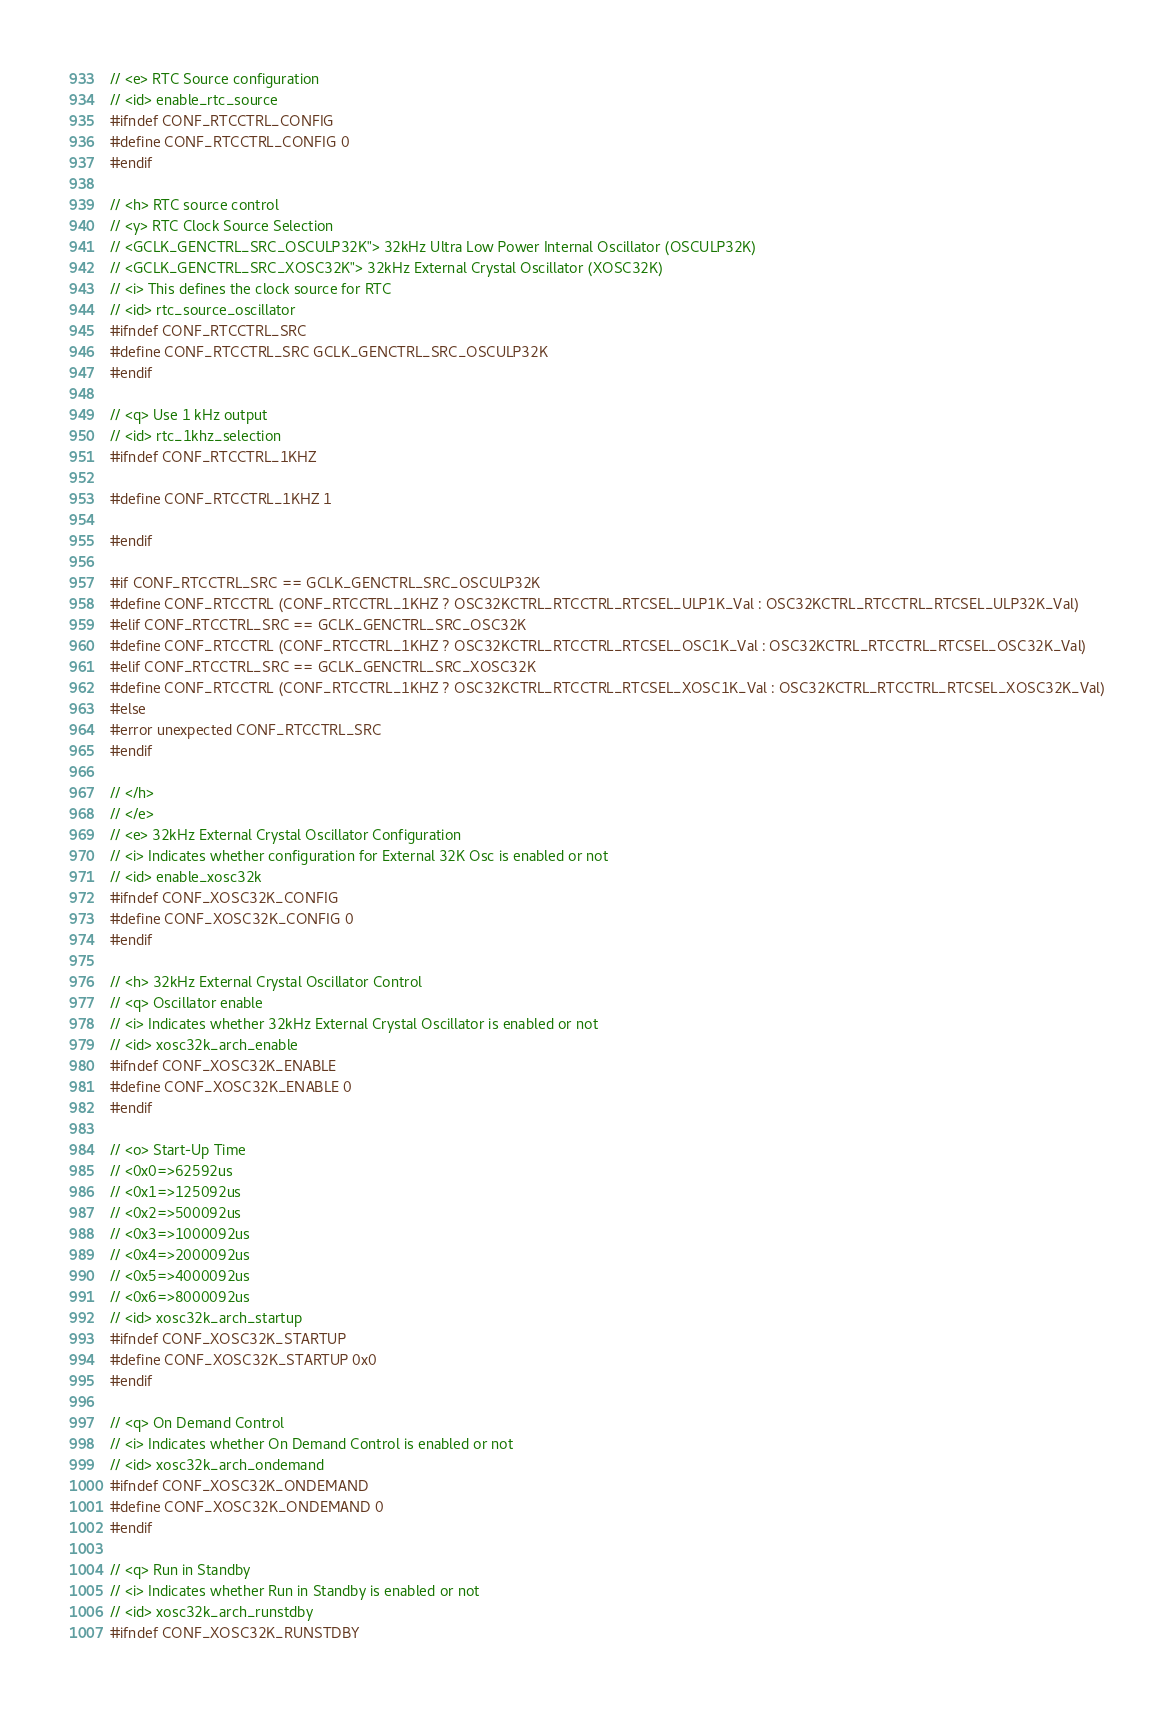<code> <loc_0><loc_0><loc_500><loc_500><_C_>
// <e> RTC Source configuration
// <id> enable_rtc_source
#ifndef CONF_RTCCTRL_CONFIG
#define CONF_RTCCTRL_CONFIG 0
#endif

// <h> RTC source control
// <y> RTC Clock Source Selection
// <GCLK_GENCTRL_SRC_OSCULP32K"> 32kHz Ultra Low Power Internal Oscillator (OSCULP32K)
// <GCLK_GENCTRL_SRC_XOSC32K"> 32kHz External Crystal Oscillator (XOSC32K)
// <i> This defines the clock source for RTC
// <id> rtc_source_oscillator
#ifndef CONF_RTCCTRL_SRC
#define CONF_RTCCTRL_SRC GCLK_GENCTRL_SRC_OSCULP32K
#endif

// <q> Use 1 kHz output
// <id> rtc_1khz_selection
#ifndef CONF_RTCCTRL_1KHZ

#define CONF_RTCCTRL_1KHZ 1

#endif

#if CONF_RTCCTRL_SRC == GCLK_GENCTRL_SRC_OSCULP32K
#define CONF_RTCCTRL (CONF_RTCCTRL_1KHZ ? OSC32KCTRL_RTCCTRL_RTCSEL_ULP1K_Val : OSC32KCTRL_RTCCTRL_RTCSEL_ULP32K_Val)
#elif CONF_RTCCTRL_SRC == GCLK_GENCTRL_SRC_OSC32K
#define CONF_RTCCTRL (CONF_RTCCTRL_1KHZ ? OSC32KCTRL_RTCCTRL_RTCSEL_OSC1K_Val : OSC32KCTRL_RTCCTRL_RTCSEL_OSC32K_Val)
#elif CONF_RTCCTRL_SRC == GCLK_GENCTRL_SRC_XOSC32K
#define CONF_RTCCTRL (CONF_RTCCTRL_1KHZ ? OSC32KCTRL_RTCCTRL_RTCSEL_XOSC1K_Val : OSC32KCTRL_RTCCTRL_RTCSEL_XOSC32K_Val)
#else
#error unexpected CONF_RTCCTRL_SRC
#endif

// </h>
// </e>
// <e> 32kHz External Crystal Oscillator Configuration
// <i> Indicates whether configuration for External 32K Osc is enabled or not
// <id> enable_xosc32k
#ifndef CONF_XOSC32K_CONFIG
#define CONF_XOSC32K_CONFIG 0
#endif

// <h> 32kHz External Crystal Oscillator Control
// <q> Oscillator enable
// <i> Indicates whether 32kHz External Crystal Oscillator is enabled or not
// <id> xosc32k_arch_enable
#ifndef CONF_XOSC32K_ENABLE
#define CONF_XOSC32K_ENABLE 0
#endif

// <o> Start-Up Time
// <0x0=>62592us
// <0x1=>125092us
// <0x2=>500092us
// <0x3=>1000092us
// <0x4=>2000092us
// <0x5=>4000092us
// <0x6=>8000092us
// <id> xosc32k_arch_startup
#ifndef CONF_XOSC32K_STARTUP
#define CONF_XOSC32K_STARTUP 0x0
#endif

// <q> On Demand Control
// <i> Indicates whether On Demand Control is enabled or not
// <id> xosc32k_arch_ondemand
#ifndef CONF_XOSC32K_ONDEMAND
#define CONF_XOSC32K_ONDEMAND 0
#endif

// <q> Run in Standby
// <i> Indicates whether Run in Standby is enabled or not
// <id> xosc32k_arch_runstdby
#ifndef CONF_XOSC32K_RUNSTDBY</code> 